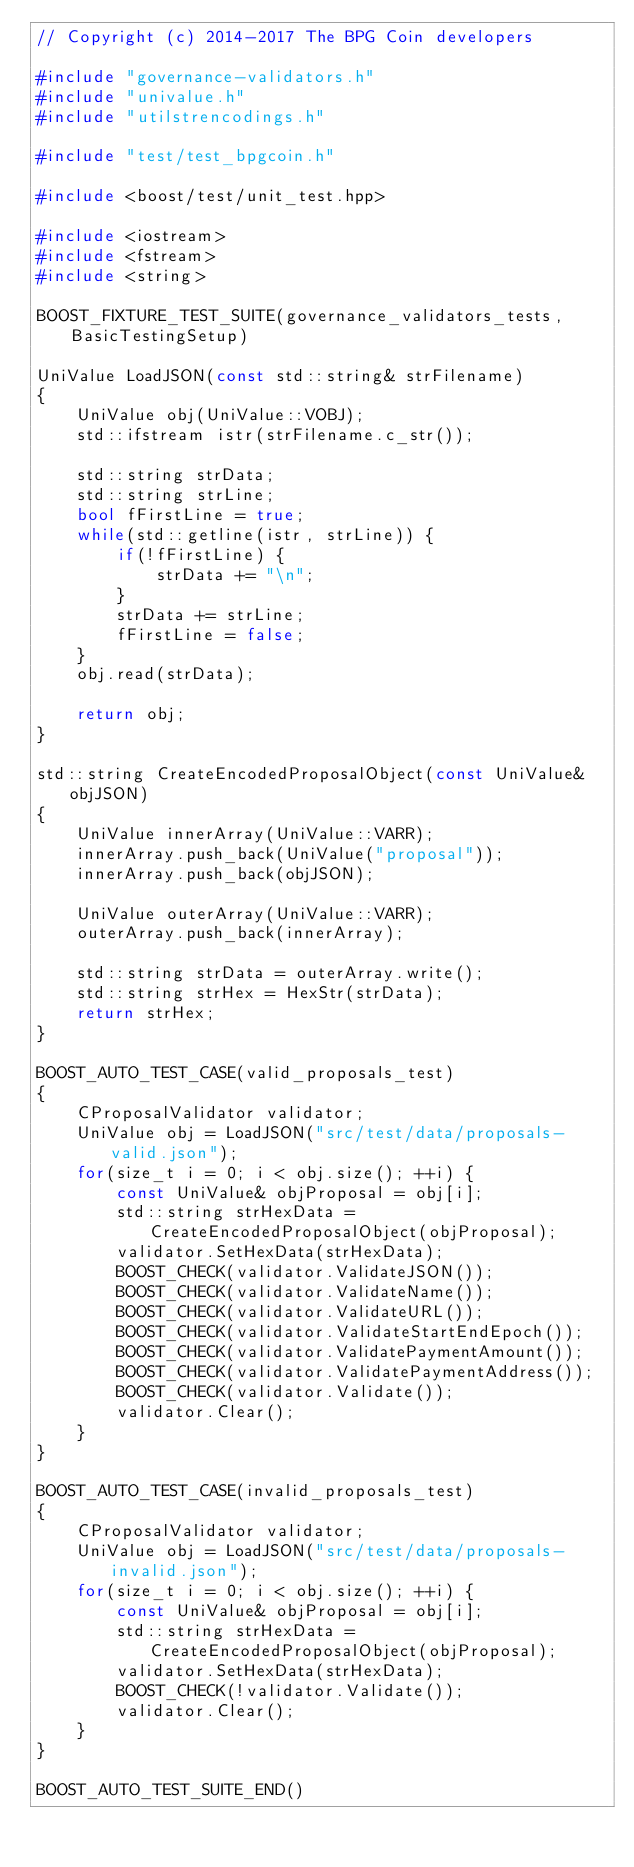<code> <loc_0><loc_0><loc_500><loc_500><_C++_>// Copyright (c) 2014-2017 The BPG Coin developers

#include "governance-validators.h"
#include "univalue.h"
#include "utilstrencodings.h"

#include "test/test_bpgcoin.h"

#include <boost/test/unit_test.hpp>

#include <iostream>
#include <fstream>
#include <string>

BOOST_FIXTURE_TEST_SUITE(governance_validators_tests, BasicTestingSetup)

UniValue LoadJSON(const std::string& strFilename)
{
    UniValue obj(UniValue::VOBJ);
    std::ifstream istr(strFilename.c_str());

    std::string strData;
    std::string strLine;
    bool fFirstLine = true;
    while(std::getline(istr, strLine)) {
        if(!fFirstLine) {
            strData += "\n";
        }
        strData += strLine;
        fFirstLine = false;
    }
    obj.read(strData);

    return obj;
}

std::string CreateEncodedProposalObject(const UniValue& objJSON)
{
    UniValue innerArray(UniValue::VARR);
    innerArray.push_back(UniValue("proposal"));
    innerArray.push_back(objJSON);

    UniValue outerArray(UniValue::VARR);
    outerArray.push_back(innerArray);
    
    std::string strData = outerArray.write();
    std::string strHex = HexStr(strData);
    return strHex;
}

BOOST_AUTO_TEST_CASE(valid_proposals_test)
{
    CProposalValidator validator;
    UniValue obj = LoadJSON("src/test/data/proposals-valid.json");
    for(size_t i = 0; i < obj.size(); ++i) {
        const UniValue& objProposal = obj[i];
        std::string strHexData = CreateEncodedProposalObject(objProposal);
        validator.SetHexData(strHexData);
        BOOST_CHECK(validator.ValidateJSON());
        BOOST_CHECK(validator.ValidateName());
        BOOST_CHECK(validator.ValidateURL());
        BOOST_CHECK(validator.ValidateStartEndEpoch());
        BOOST_CHECK(validator.ValidatePaymentAmount());
        BOOST_CHECK(validator.ValidatePaymentAddress());
        BOOST_CHECK(validator.Validate());
        validator.Clear();
    }
}

BOOST_AUTO_TEST_CASE(invalid_proposals_test)
{
    CProposalValidator validator;
    UniValue obj = LoadJSON("src/test/data/proposals-invalid.json");
    for(size_t i = 0; i < obj.size(); ++i) {
        const UniValue& objProposal = obj[i];
        std::string strHexData = CreateEncodedProposalObject(objProposal);
        validator.SetHexData(strHexData);
        BOOST_CHECK(!validator.Validate());
        validator.Clear();
    }
}

BOOST_AUTO_TEST_SUITE_END()
</code> 